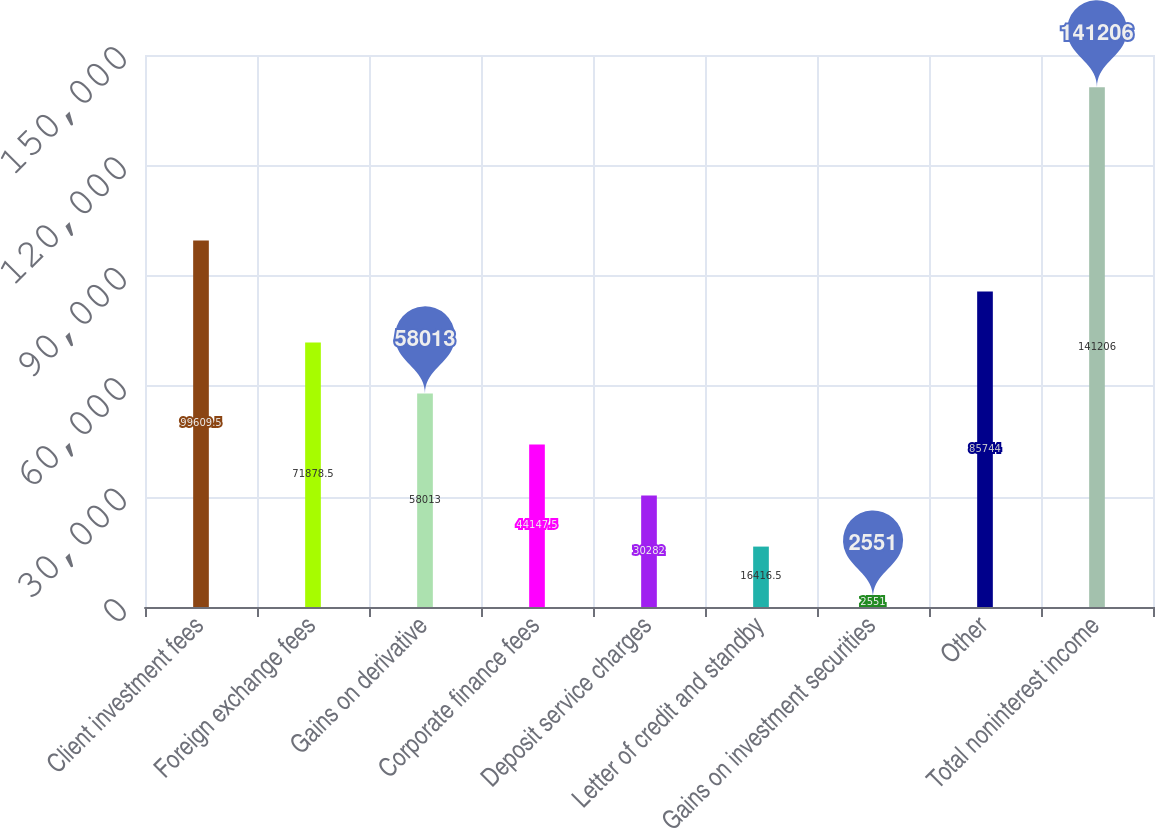Convert chart. <chart><loc_0><loc_0><loc_500><loc_500><bar_chart><fcel>Client investment fees<fcel>Foreign exchange fees<fcel>Gains on derivative<fcel>Corporate finance fees<fcel>Deposit service charges<fcel>Letter of credit and standby<fcel>Gains on investment securities<fcel>Other<fcel>Total noninterest income<nl><fcel>99609.5<fcel>71878.5<fcel>58013<fcel>44147.5<fcel>30282<fcel>16416.5<fcel>2551<fcel>85744<fcel>141206<nl></chart> 